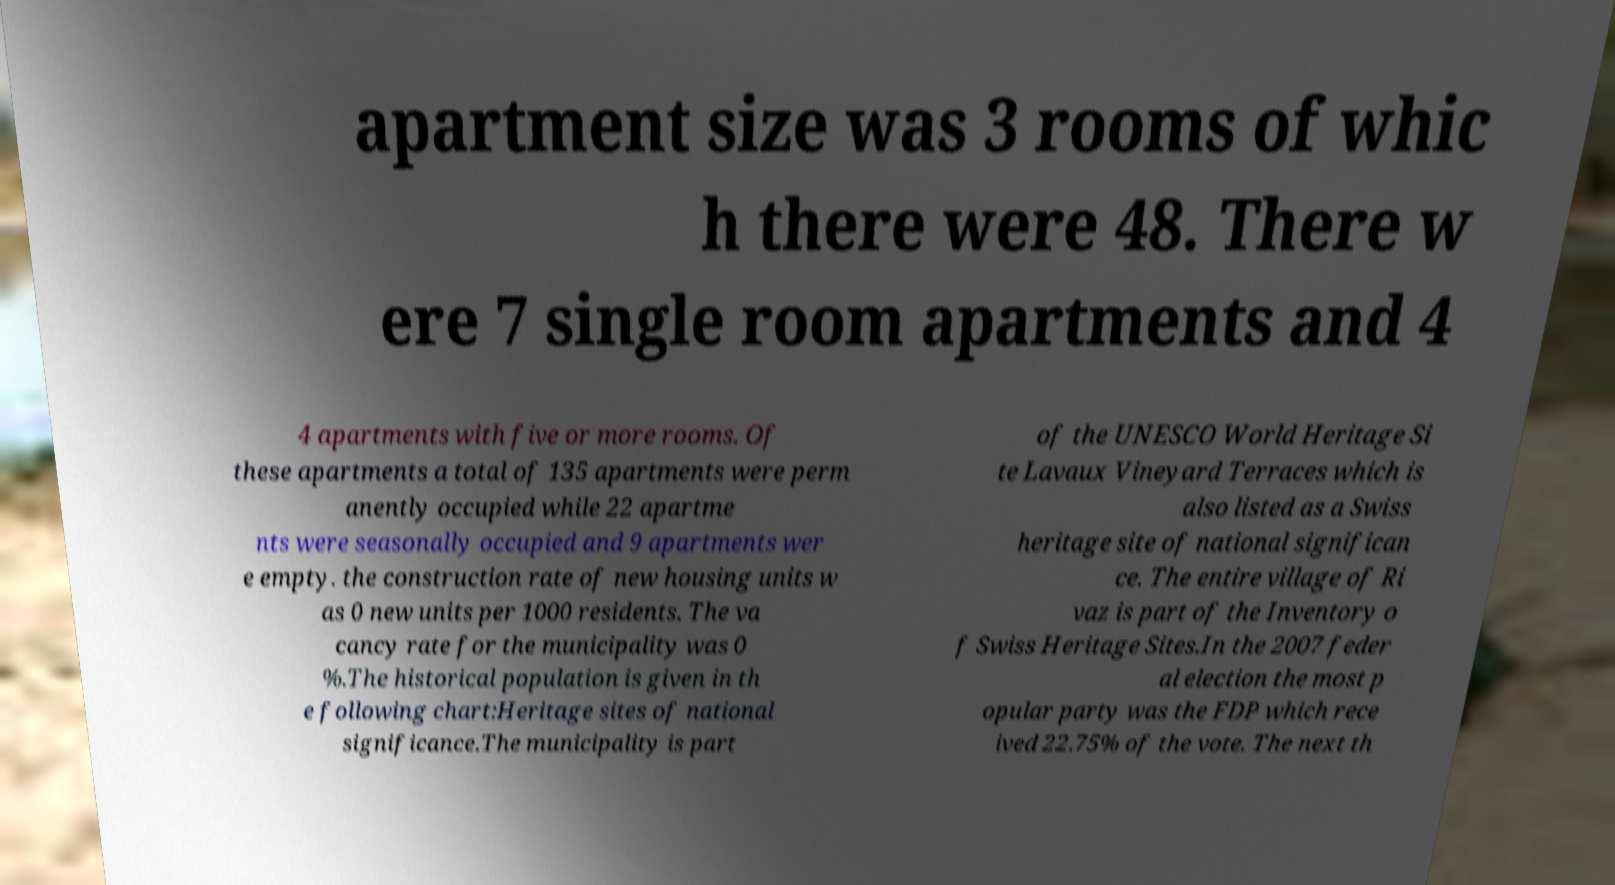Can you read and provide the text displayed in the image?This photo seems to have some interesting text. Can you extract and type it out for me? apartment size was 3 rooms of whic h there were 48. There w ere 7 single room apartments and 4 4 apartments with five or more rooms. Of these apartments a total of 135 apartments were perm anently occupied while 22 apartme nts were seasonally occupied and 9 apartments wer e empty. the construction rate of new housing units w as 0 new units per 1000 residents. The va cancy rate for the municipality was 0 %.The historical population is given in th e following chart:Heritage sites of national significance.The municipality is part of the UNESCO World Heritage Si te Lavaux Vineyard Terraces which is also listed as a Swiss heritage site of national significan ce. The entire village of Ri vaz is part of the Inventory o f Swiss Heritage Sites.In the 2007 feder al election the most p opular party was the FDP which rece ived 22.75% of the vote. The next th 